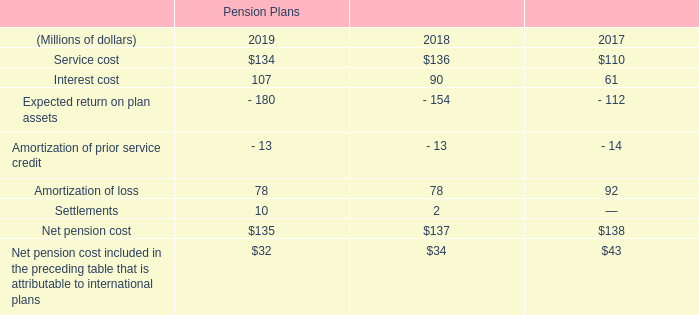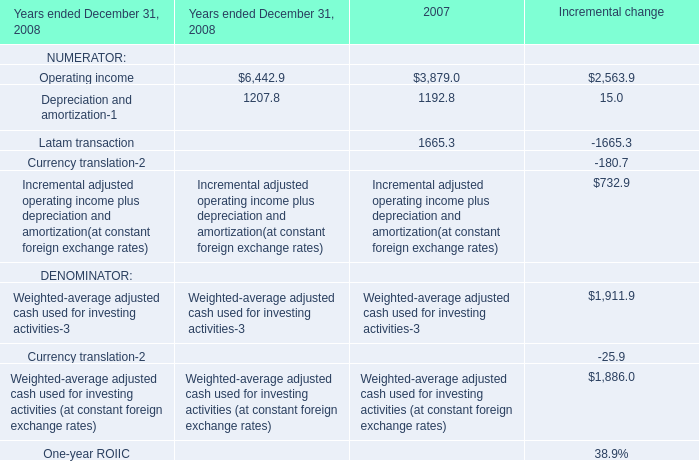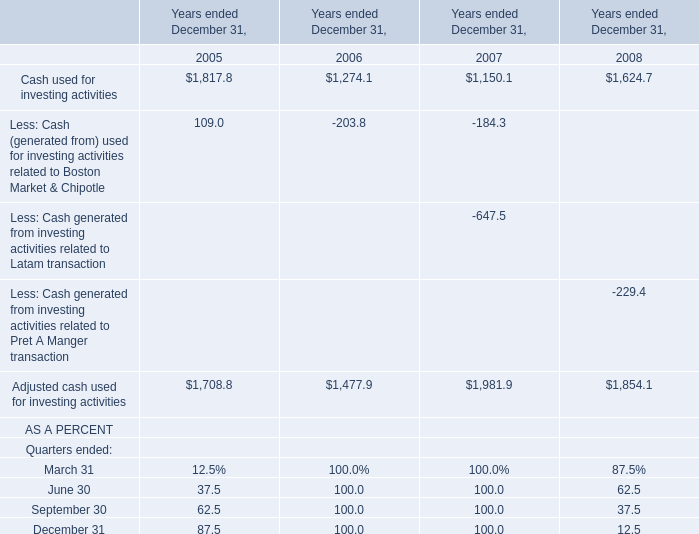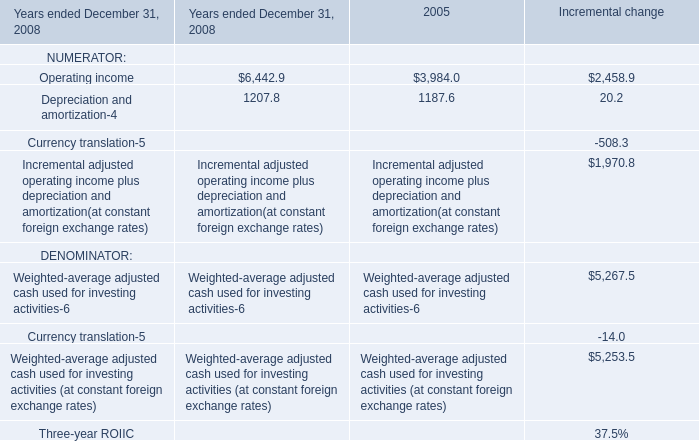What's the average of Depreciation and amortization of 2005, and Depreciation and amortization of 2007 ? 
Computations: ((1207.8 + 1207.8) / 2)
Answer: 1207.8. 